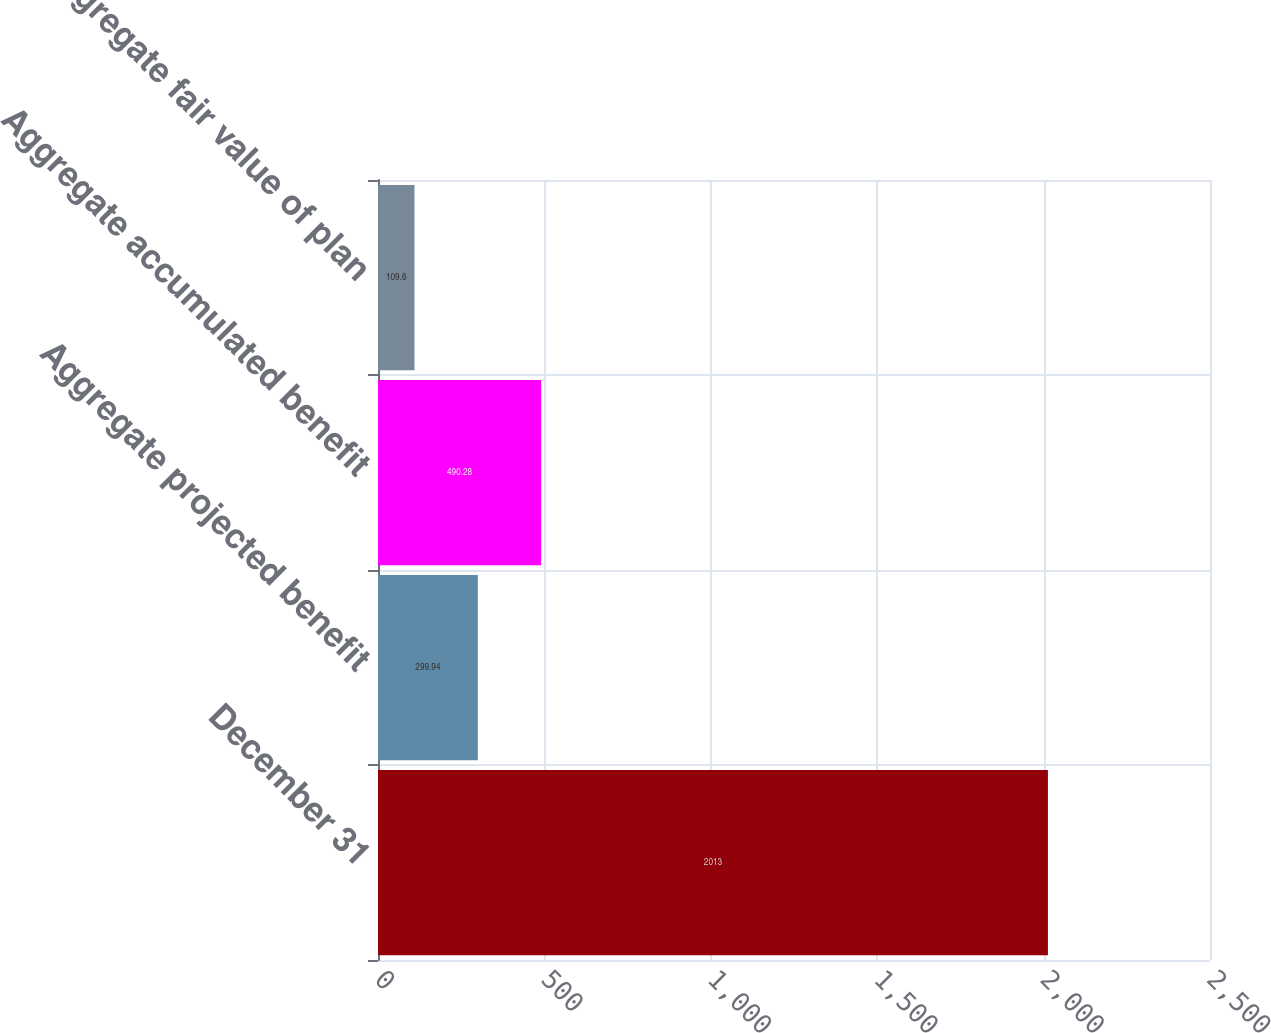Convert chart. <chart><loc_0><loc_0><loc_500><loc_500><bar_chart><fcel>December 31<fcel>Aggregate projected benefit<fcel>Aggregate accumulated benefit<fcel>Aggregate fair value of plan<nl><fcel>2013<fcel>299.94<fcel>490.28<fcel>109.6<nl></chart> 